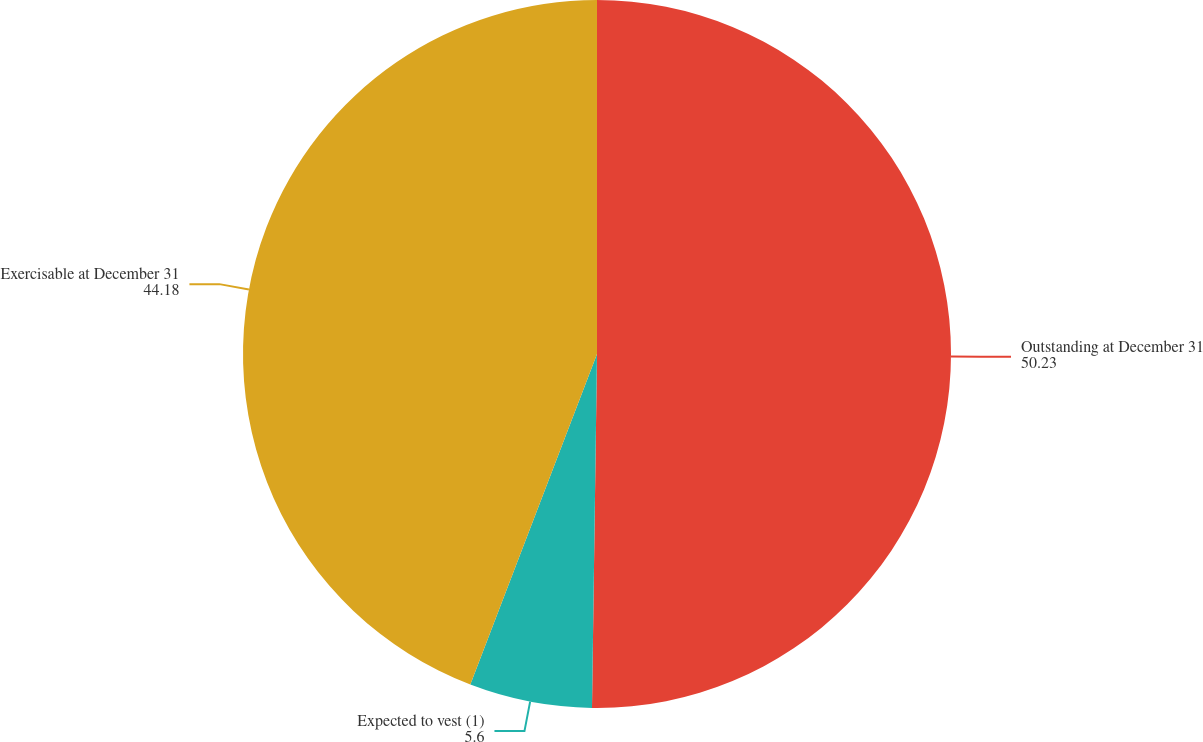<chart> <loc_0><loc_0><loc_500><loc_500><pie_chart><fcel>Outstanding at December 31<fcel>Expected to vest (1)<fcel>Exercisable at December 31<nl><fcel>50.23%<fcel>5.6%<fcel>44.18%<nl></chart> 